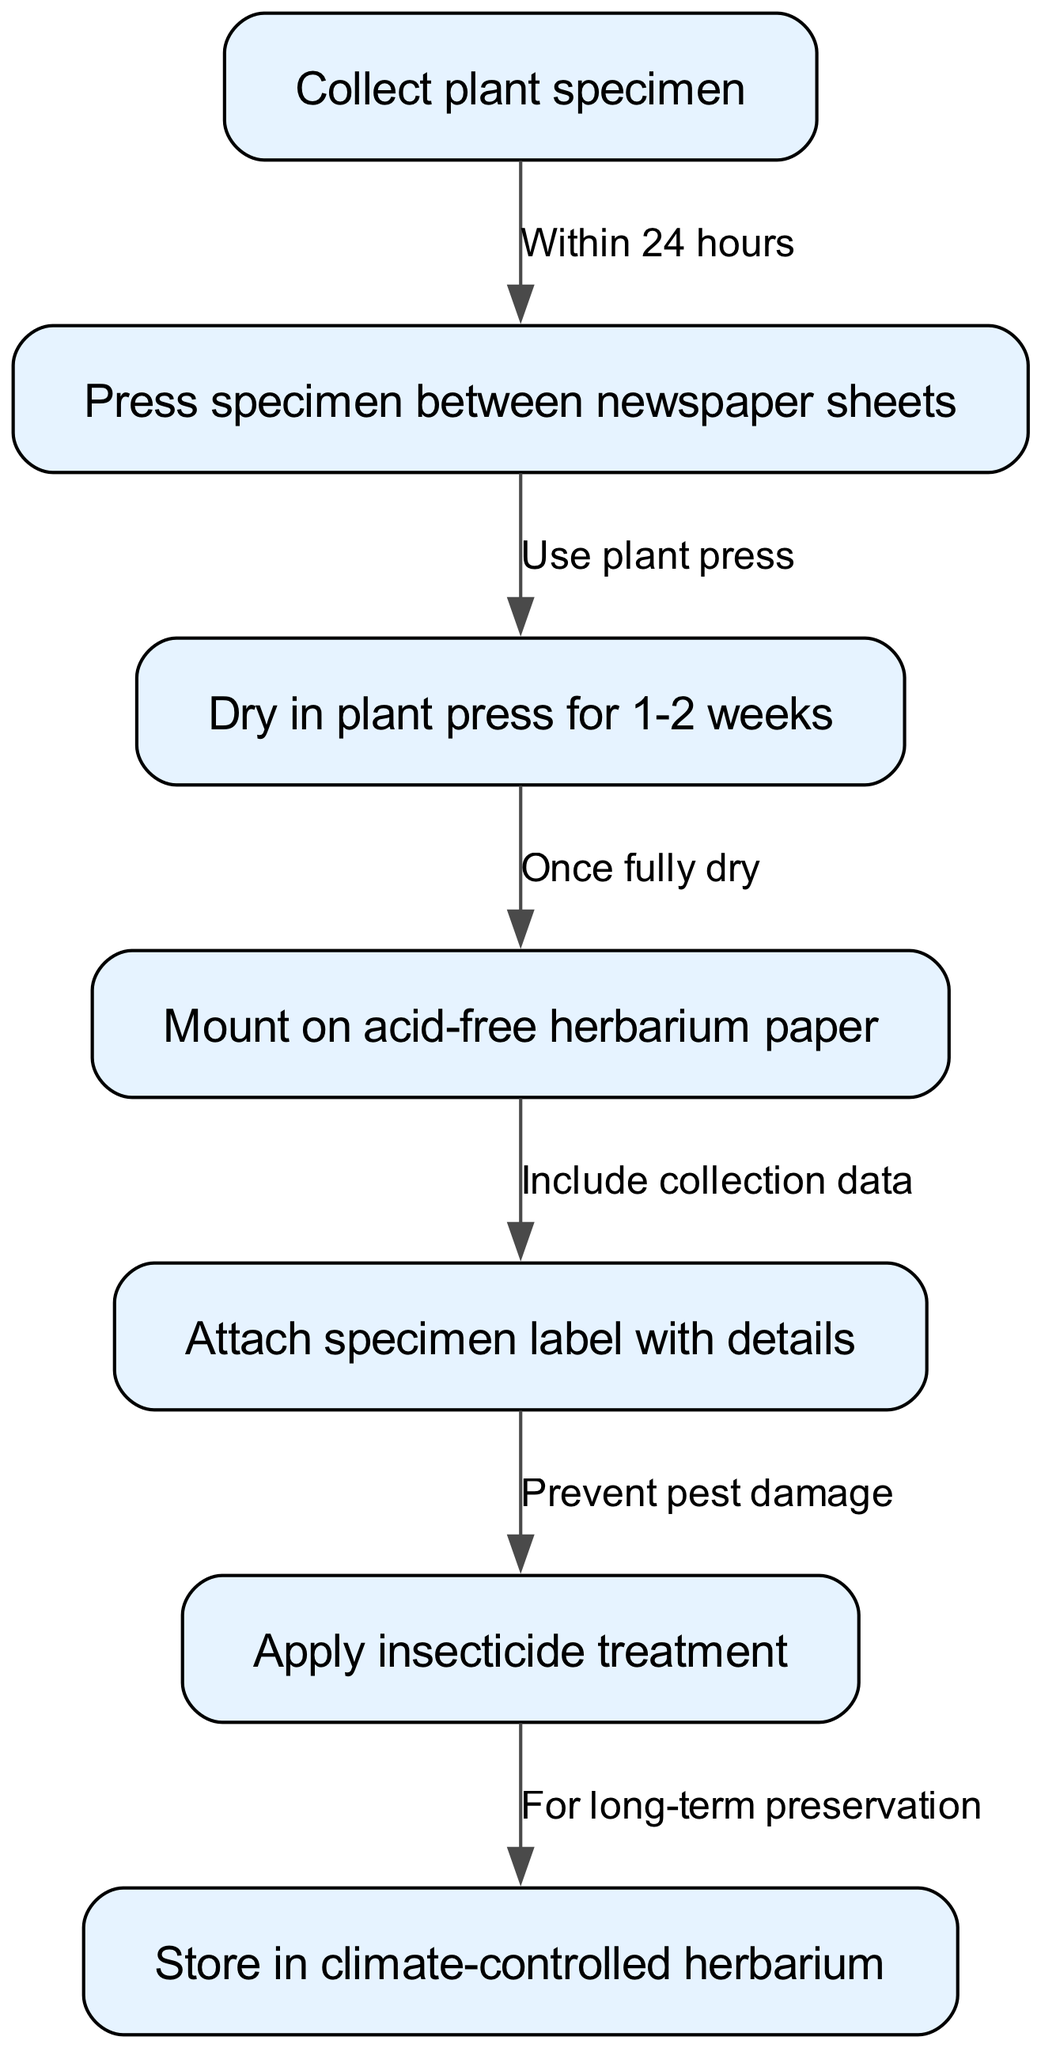What is the first step in the herbarium specimen preparation process? The first node in the diagram, which represents the starting point of the process, indicates that the first step is to "Collect plant specimen."
Answer: Collect plant specimen How long should the specimen be dried in the plant press? The edge leading from the "Dry in plant press" node specifies that the duration for drying is "1-2 weeks."
Answer: 1-2 weeks What is attached after mounting the specimen on the herbarium paper? The flow from the "Mount on acid-free herbarium paper" node to the next node indicates that a "specimen label with details" is attached next.
Answer: Specimen label with details What is the purpose of applying insecticide treatment? The edge between the "Attach specimen label with details" and "Apply insecticide treatment" nodes states this action is done to "Prevent pest damage," which clarifies the purpose of the insecticide.
Answer: Prevent pest damage How many nodes are present in the herbarium specimen preparation flow chart? Counting all the distinct nodes in the diagram, there are seven defined nodes related to the process.
Answer: 7 Once the specimen is fully dry, what is the next step? There is a directed edge that shows the transition from the "Dry in plant press" node to the "Mount on acid-free herbarium paper" node once the specimen is fully dry.
Answer: Mount on acid-free herbarium paper What is the last step in the herbarium specimen preservation process? The final node in the flow chart indicates that the last step is to "Store in climate-controlled herbarium."
Answer: Store in climate-controlled herbarium What action is taken for long-term preservation of the specimen? The flow from "Apply insecticide treatment" to "Store in climate-controlled herbarium" signifies that this storage is a measure taken for long-term preservation.
Answer: Store in climate-controlled herbarium What happens immediately after collecting the plant specimen? According to the first edge leading from "Collect plant specimen," the immediate action is to "Press specimen between newspaper sheets" within 24 hours.
Answer: Press specimen between newspaper sheets 